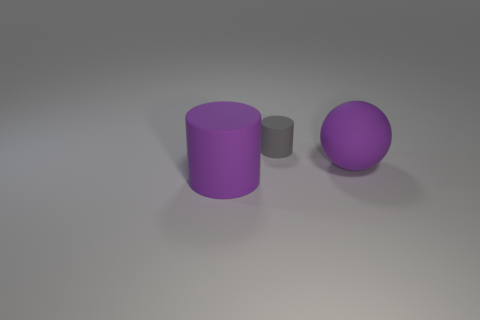How would you describe the colors and textures of the objects? The objects exhibit a minimalist color scheme with two colors: purple and gray. The large purple cylinder and sphere share a matte finish, which diffuses light evenly, softening their appearance. The smaller gray cylinder appears to have a similar surface texture, also matte, which complements the purple objects without overpowering them. 